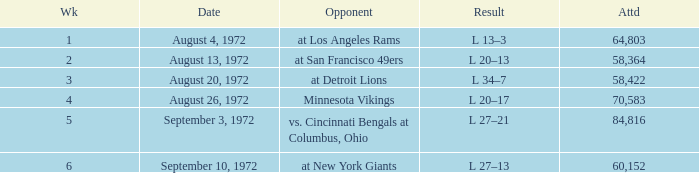How many weeks had an attendance larger than 84,816? 0.0. 